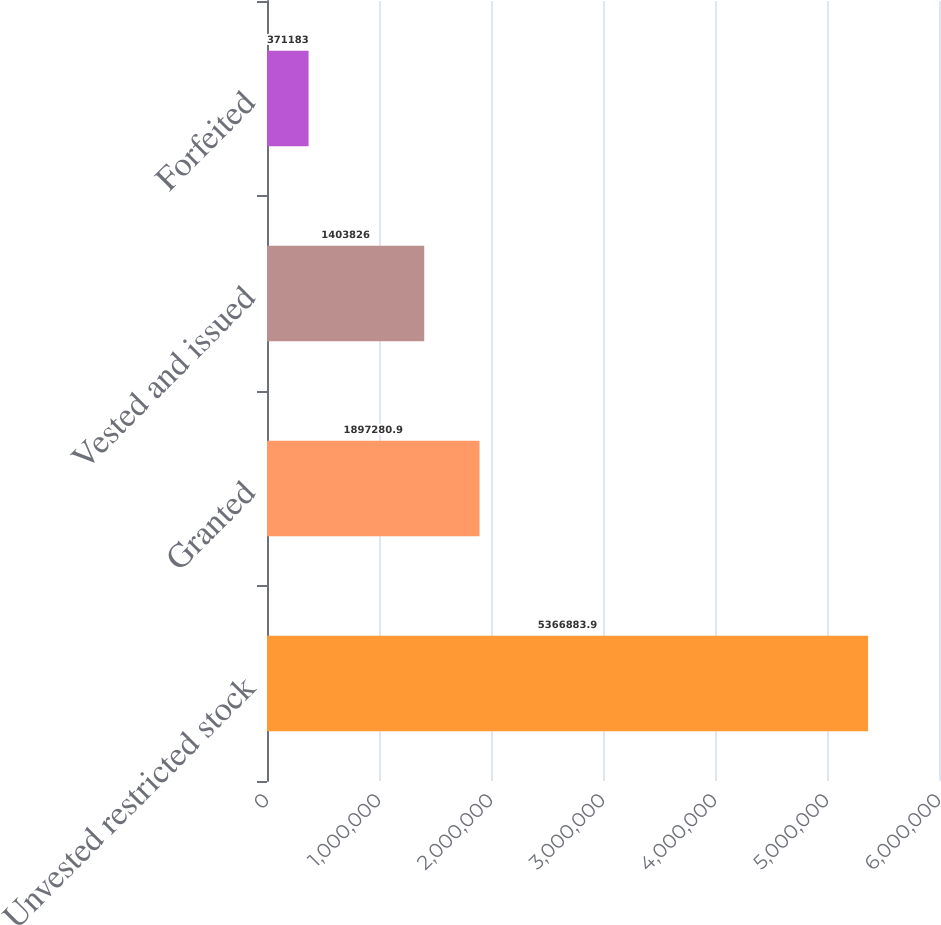Convert chart to OTSL. <chart><loc_0><loc_0><loc_500><loc_500><bar_chart><fcel>Unvested restricted stock<fcel>Granted<fcel>Vested and issued<fcel>Forfeited<nl><fcel>5.36688e+06<fcel>1.89728e+06<fcel>1.40383e+06<fcel>371183<nl></chart> 